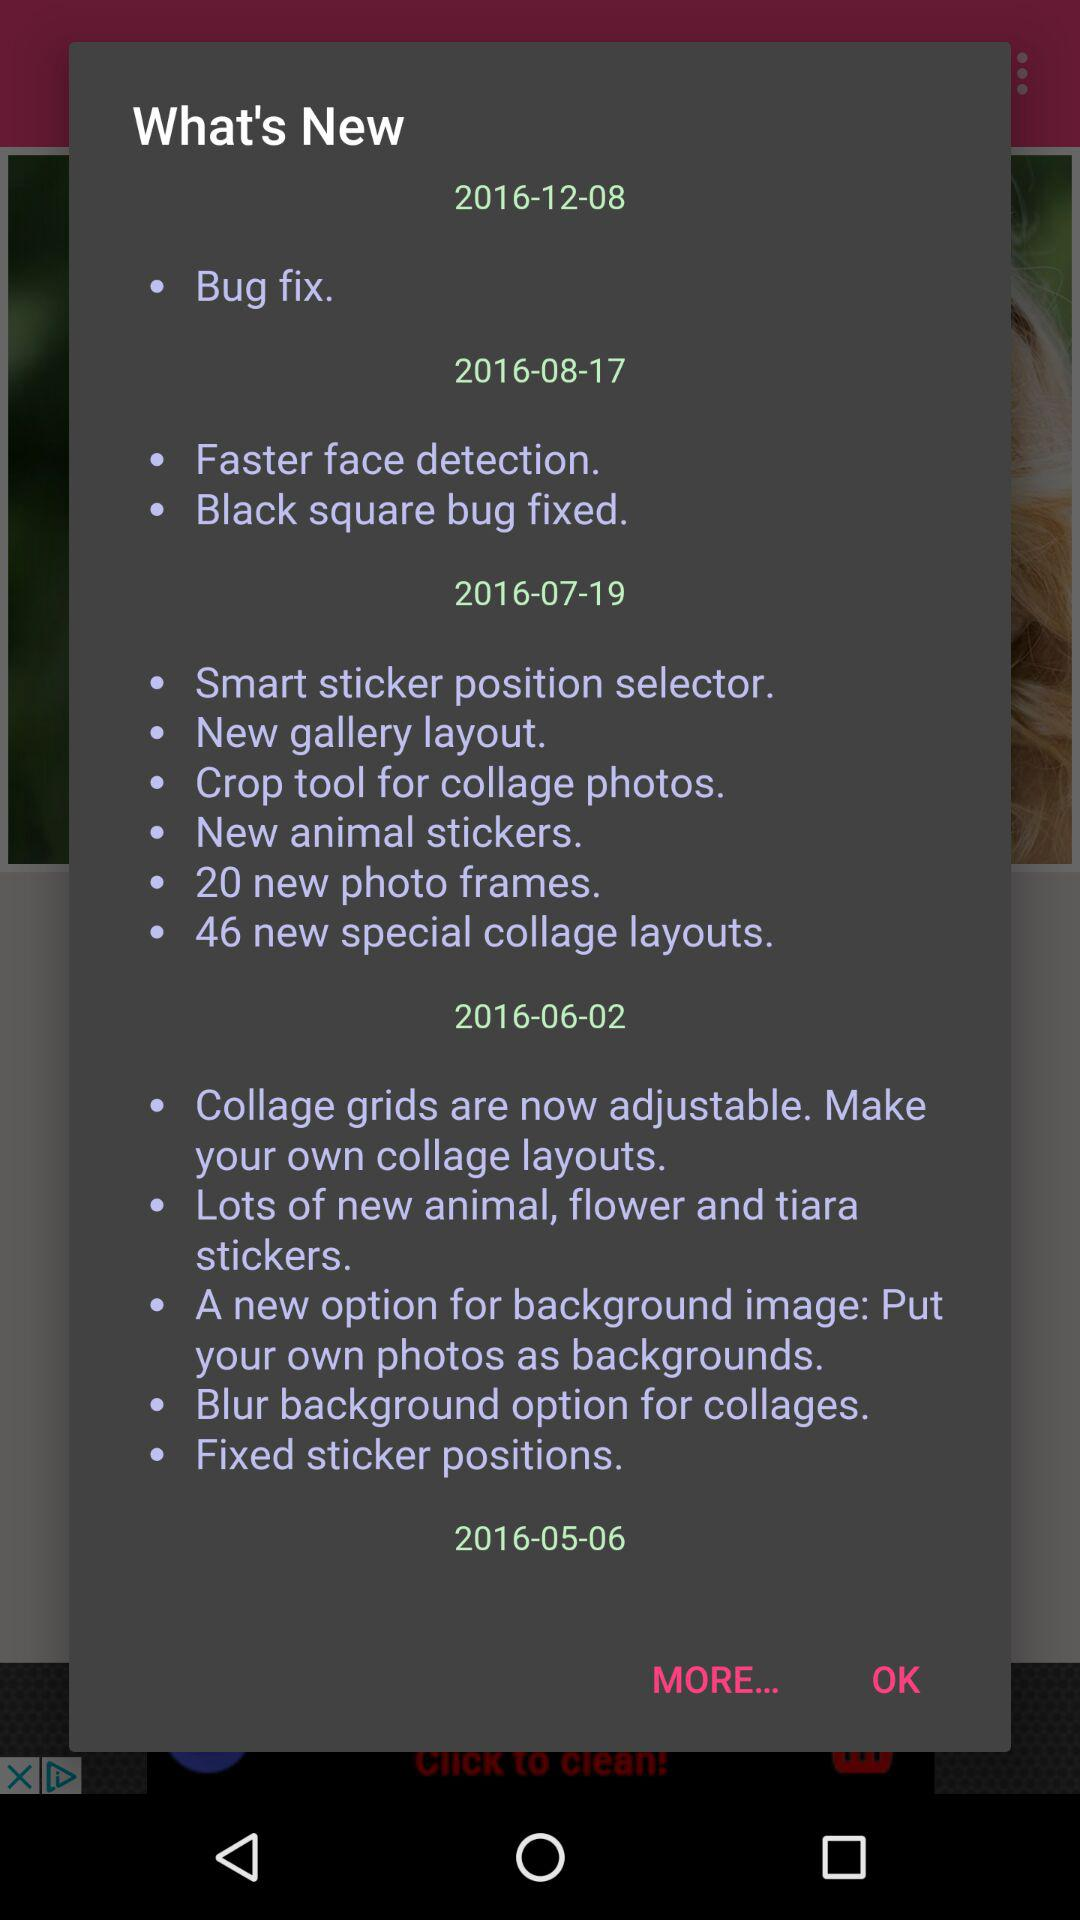What is the new information on the date 2016-06-02? The new information is "Collage grids are now adjustable. Make your own collage layouts", "Lots of new animal, flower and tiara stickers", "A new option for background image: Put your own photos as backgrounds", "Blur background option for collages", and "Fixed sticker positions.". 